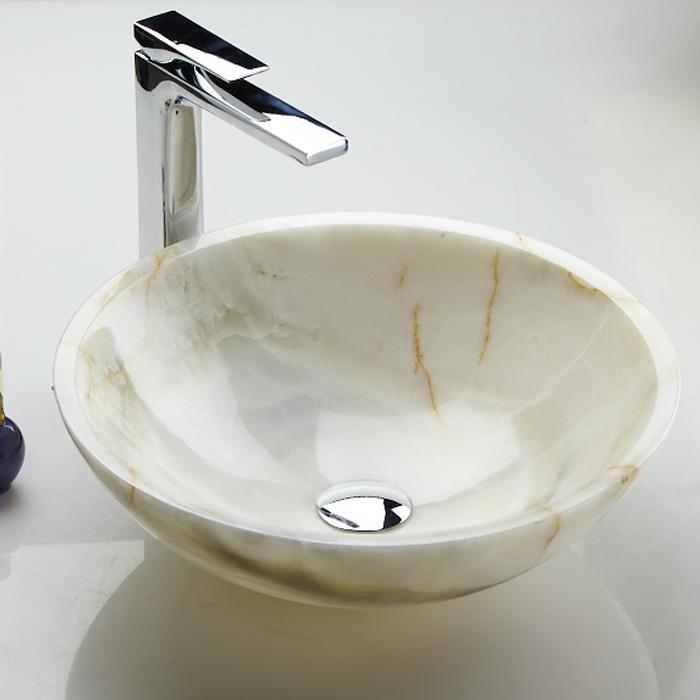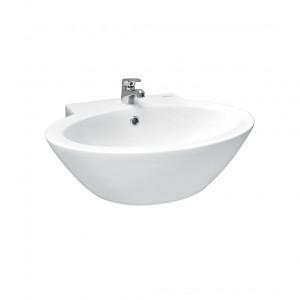The first image is the image on the left, the second image is the image on the right. Evaluate the accuracy of this statement regarding the images: "The image on the right has a plain white background.". Is it true? Answer yes or no. Yes. 